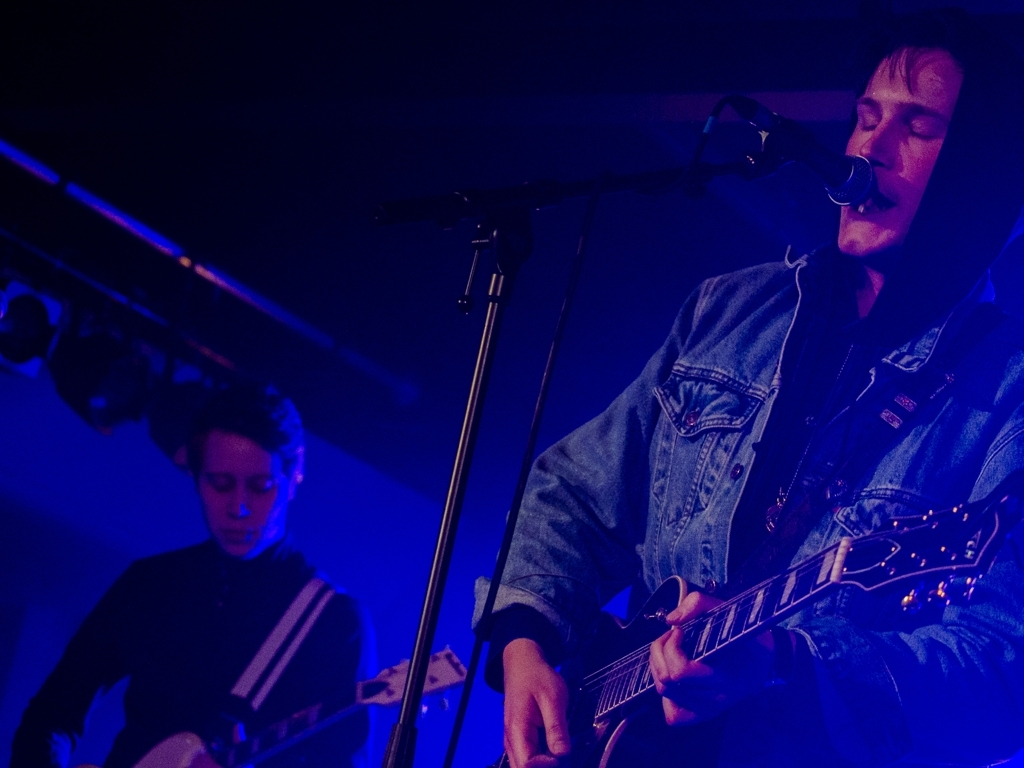How would you describe the lighting in this image? The lighting in the image appears to be moody and dramatic, with a heavy emphasis on blue and purple tones. There is a low-light ambience which suggests an intimate venue, likely a live music performance. The main subject, a guitarist, is lit with a spotlight that casts shadows on his face, enhancing the sense of depth and focus on his performance. 